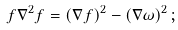Convert formula to latex. <formula><loc_0><loc_0><loc_500><loc_500>f \nabla ^ { 2 } f = ( \nabla f ) ^ { 2 } - ( \nabla \omega ) ^ { 2 } \, ;</formula> 